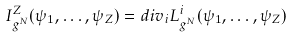<formula> <loc_0><loc_0><loc_500><loc_500>I ^ { Z } _ { g ^ { N } } ( { \psi } _ { 1 } , \dots , { \psi } _ { Z } ) = d i v _ { i } L ^ { i } _ { g ^ { N } } ( { \psi } _ { 1 } , \dots , { \psi } _ { Z } )</formula> 